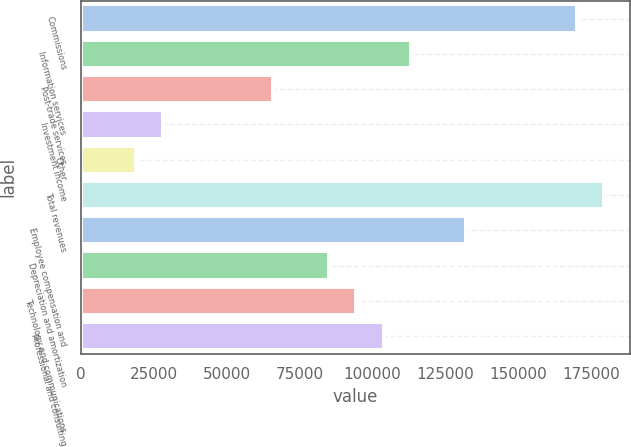<chart> <loc_0><loc_0><loc_500><loc_500><bar_chart><fcel>Commissions<fcel>Information services<fcel>Post-trade services<fcel>Investment income<fcel>Other<fcel>Total revenues<fcel>Employee compensation and<fcel>Depreciation and amortization<fcel>Technology and communications<fcel>Professional and consulting<nl><fcel>169984<fcel>113323<fcel>66105.4<fcel>28331.4<fcel>18887.9<fcel>179428<fcel>132210<fcel>84992.5<fcel>94436<fcel>103879<nl></chart> 